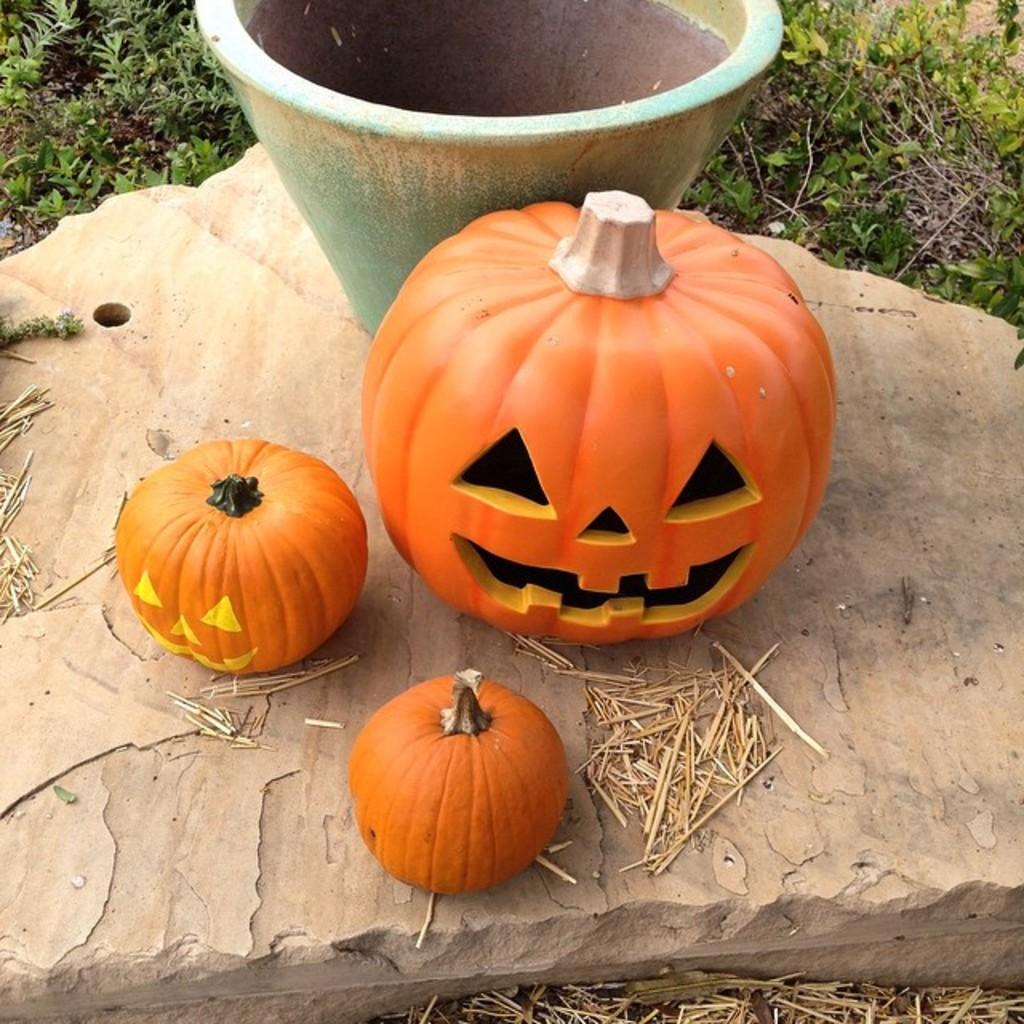How would you summarize this image in a sentence or two? In the picture I can see three pumpkins and a plant pot are kept on the rock. I can see small plants in the picture. 